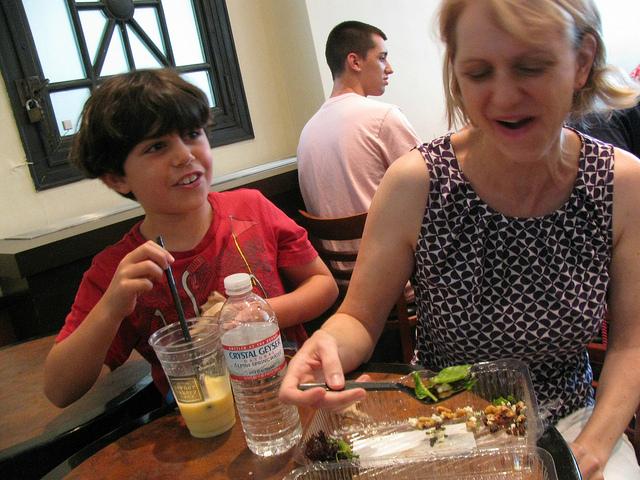Is she eating her food with a fork?
Give a very brief answer. Yes. What brand of bottled water is she drinking?
Write a very short answer. Crystal geyser. How many people do you see?
Be succinct. 3. 